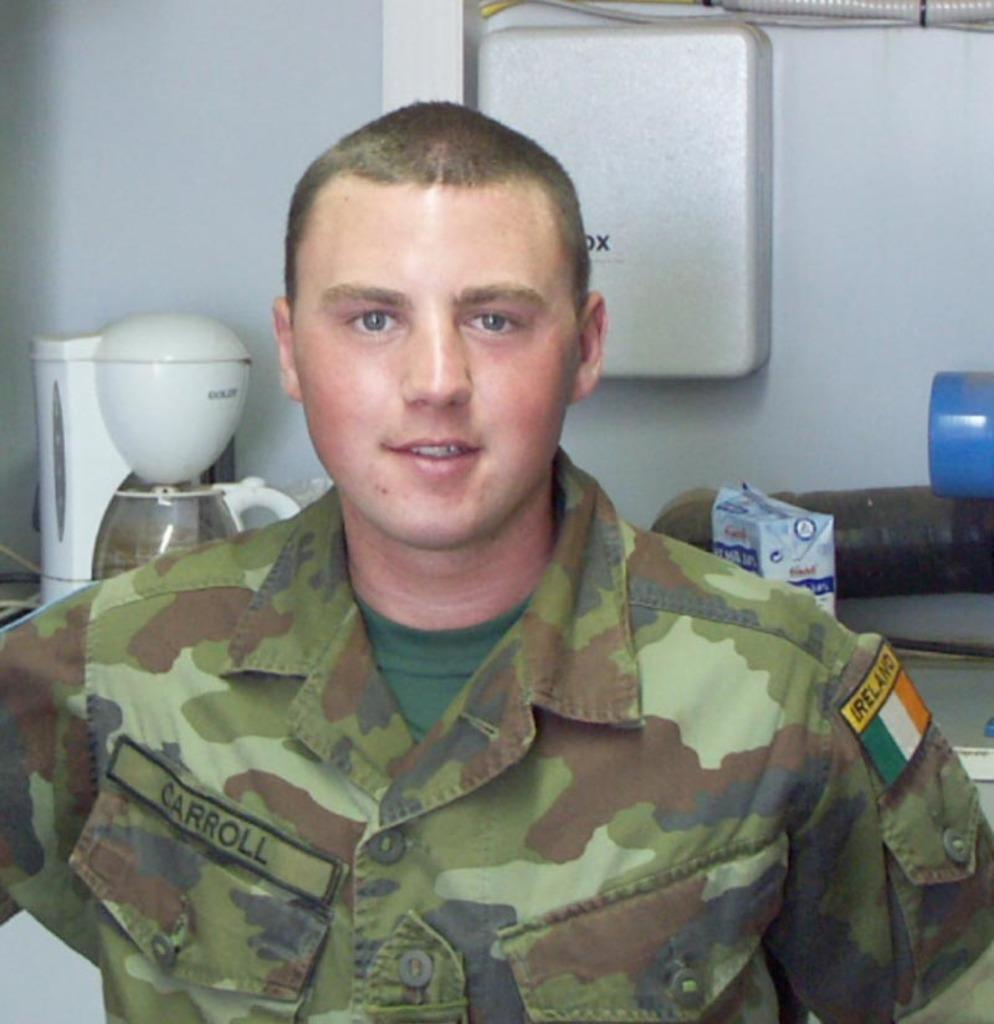<image>
Provide a brief description of the given image. Soldier Carroll is from the country of ireland. 